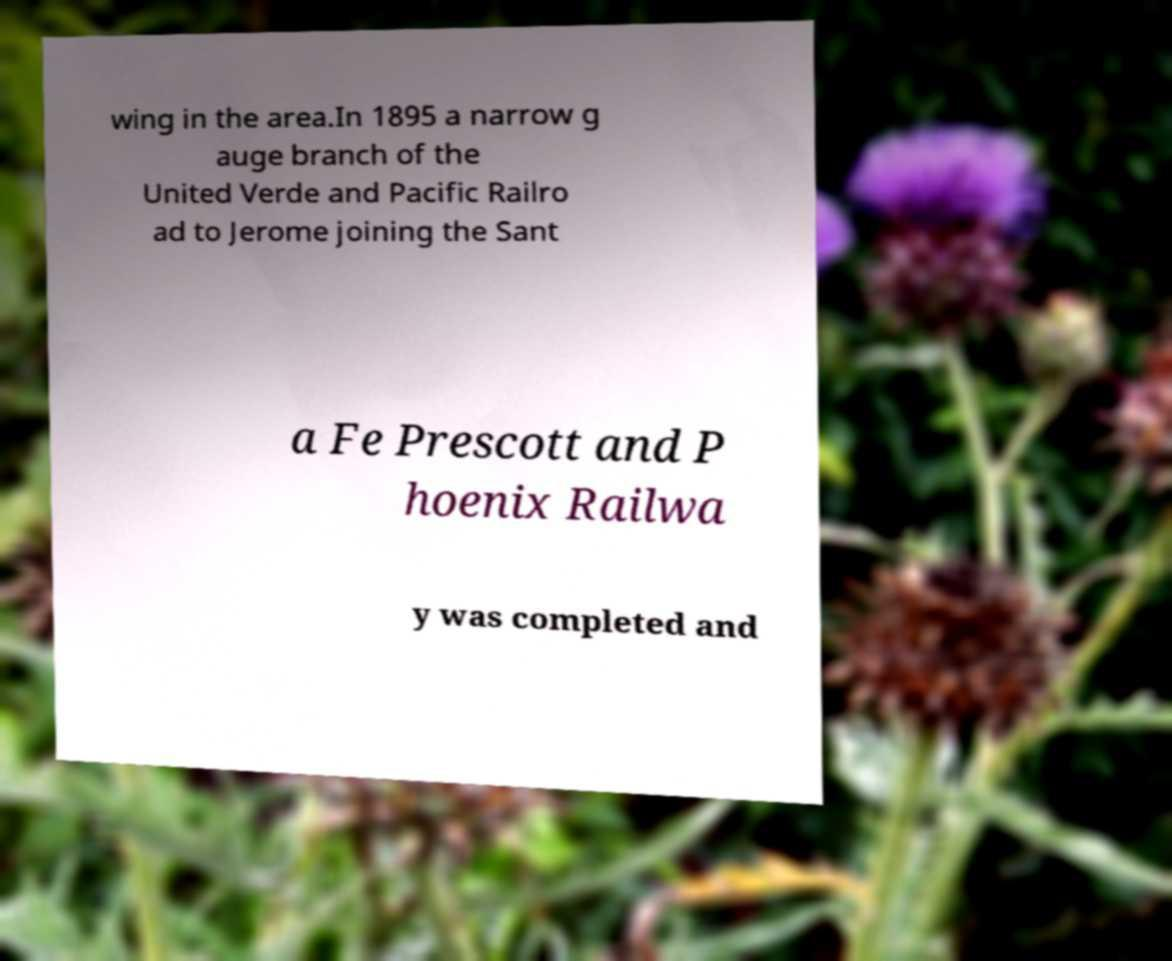Please identify and transcribe the text found in this image. wing in the area.In 1895 a narrow g auge branch of the United Verde and Pacific Railro ad to Jerome joining the Sant a Fe Prescott and P hoenix Railwa y was completed and 